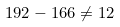Convert formula to latex. <formula><loc_0><loc_0><loc_500><loc_500>1 9 2 - 1 6 6 \neq 1 2</formula> 